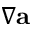Convert formula to latex. <formula><loc_0><loc_0><loc_500><loc_500>\nabla { \mathbf a }</formula> 